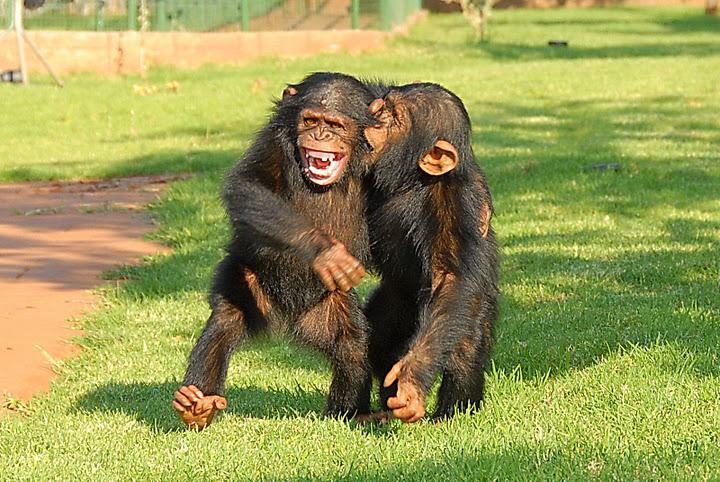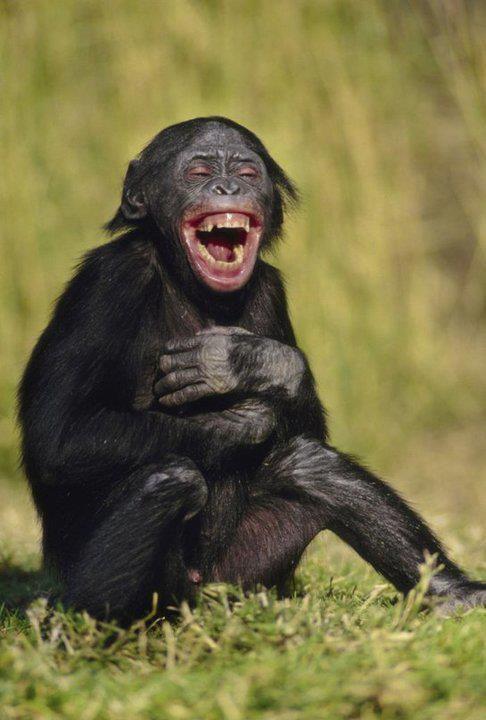The first image is the image on the left, the second image is the image on the right. Examine the images to the left and right. Is the description "An image contains one chimp, with arms folded across its chest and a wide, open grin on its face." accurate? Answer yes or no. Yes. 